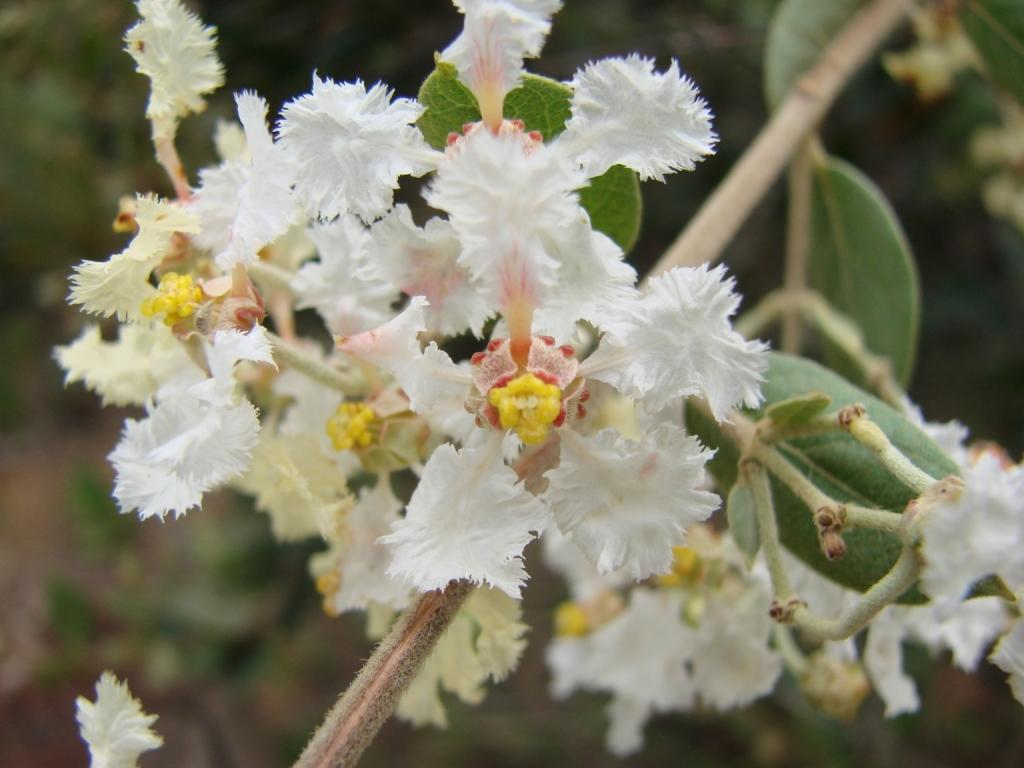What type of living organism is present in the image? There is a plant in the image. What specific feature of the plant can be observed? The plant has flowers. What color are the flowers on the plant? The flowers are white in color. What type of suggestion can be seen in the image? There is no suggestion present in the image; it features a plant with white flowers. Is there a prison visible in the image? No, there is no prison present in the image. 